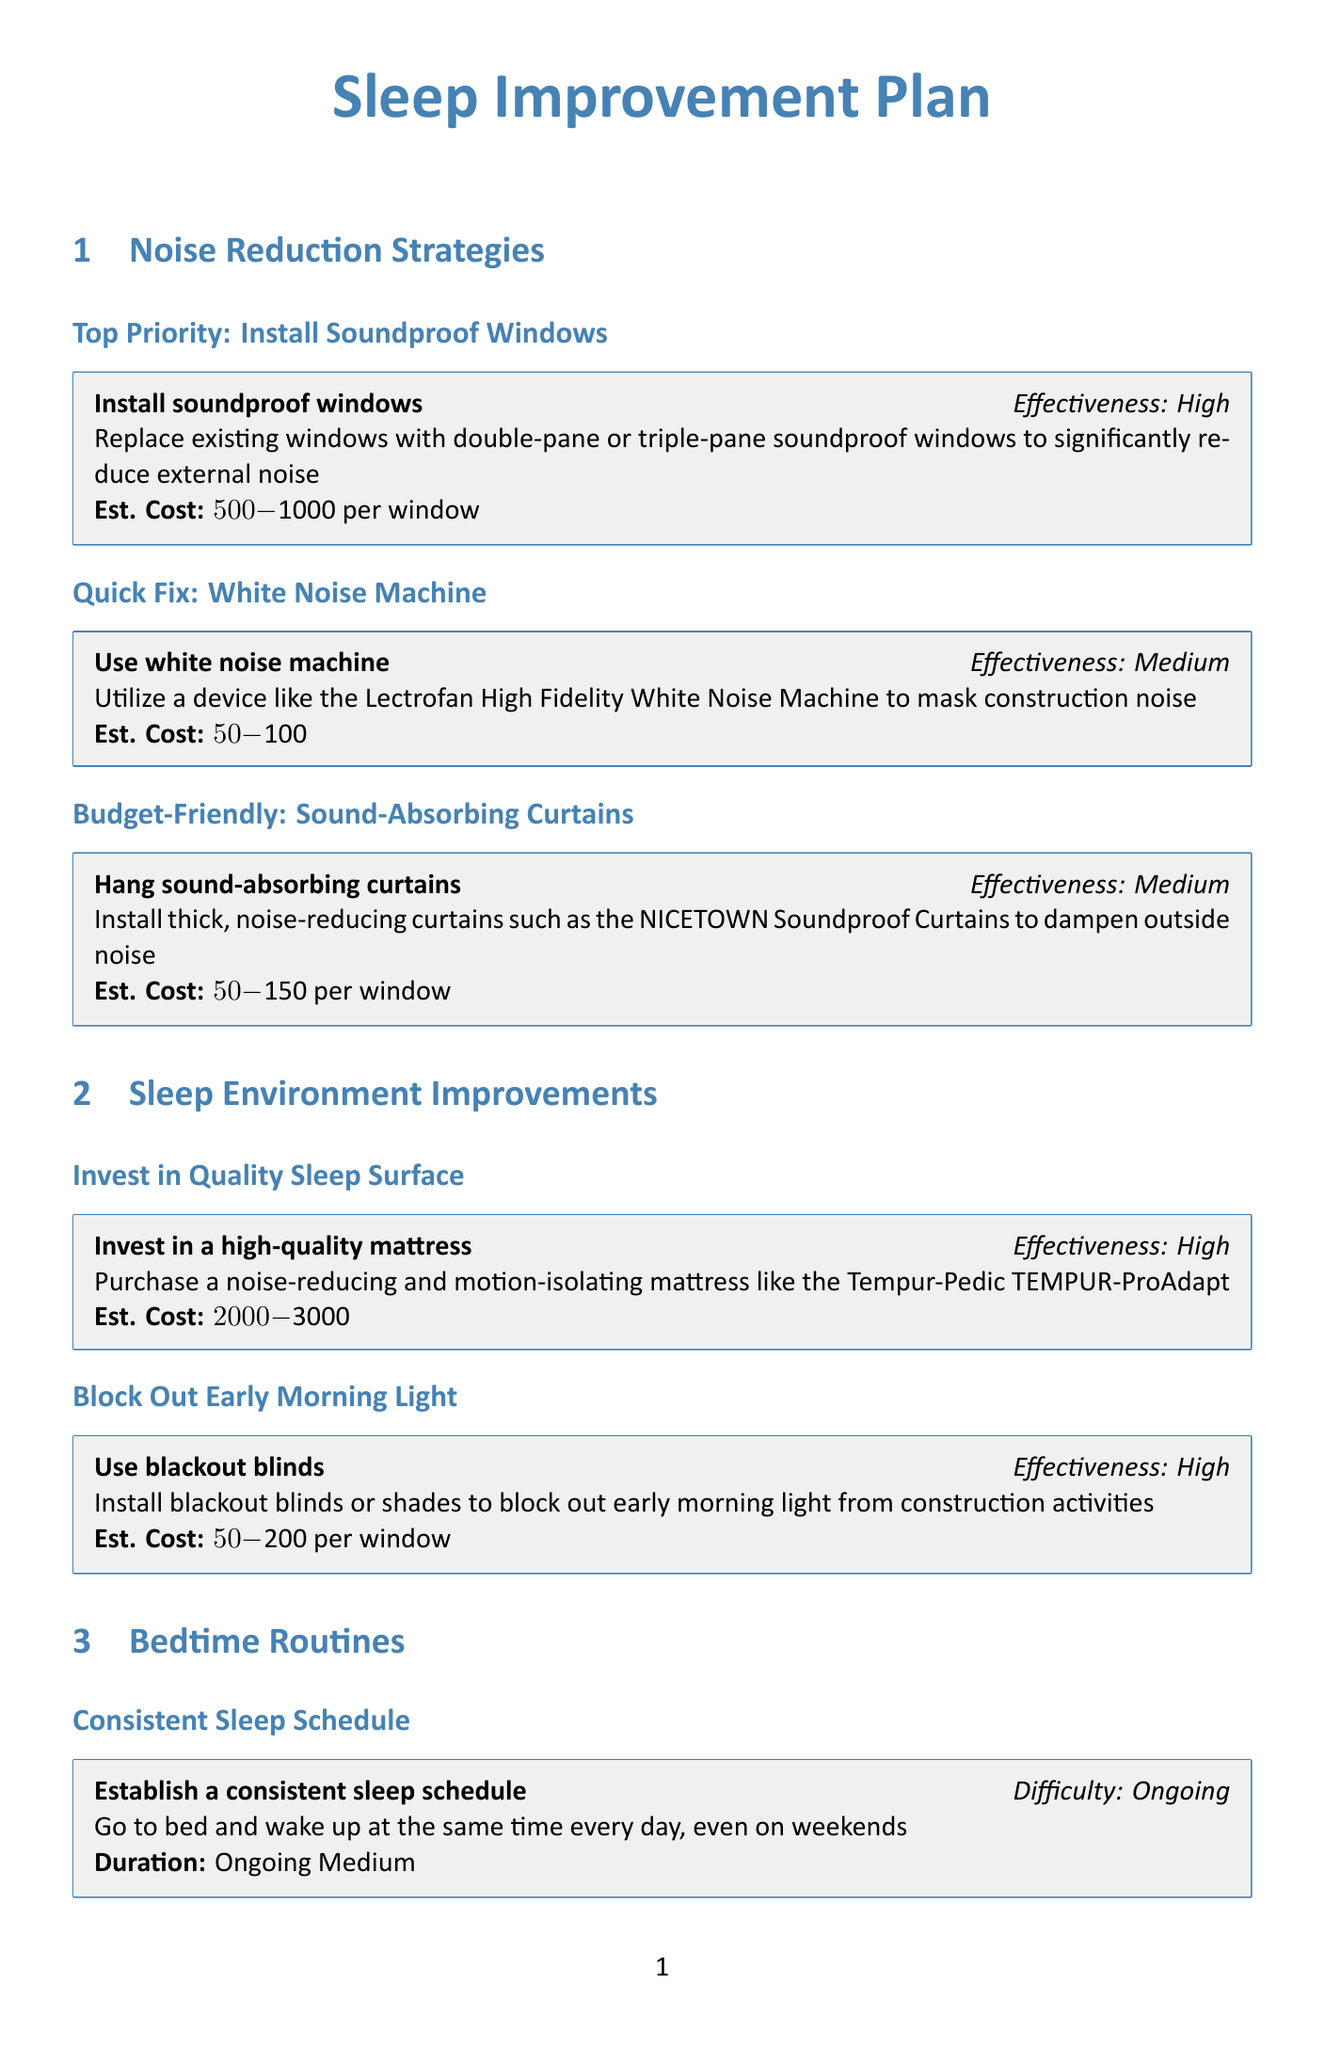What is the estimated cost of soundproof windows? The estimated cost is provided in the document as a range for soundproof windows.
Answer: $500-$1000 per window What is the effectiveness rating for hanging sound-absorbing curtains? The effectiveness of hanging sound-absorbing curtains is listed in the document.
Answer: Medium How long should screen time be limited before bedtime? The document specifies the duration for limiting screen time before bedtime.
Answer: 1 hour What is suggested for managing stress? The document describes a technique recommended for managing stress relating to construction noise.
Answer: Mindfulness or yoga What is the estimated cost range for melatonin supplements? The document mentions the estimated cost for melatonin supplements.
Answer: $10-$20 for a month's supply What type of blinds should be used to block out light? The document specifically suggests a type of window covering to prevent light intrusion.
Answer: Blackout blinds How long should daytime naps be limited to? The document provides information about the recommended maximum duration of daytime naps.
Answer: 20-30 minutes What is one medium effectiveness sleep aid mentioned? The document lists multiple sleep aids and asks for one with medium effectiveness.
Answer: Use earplugs 